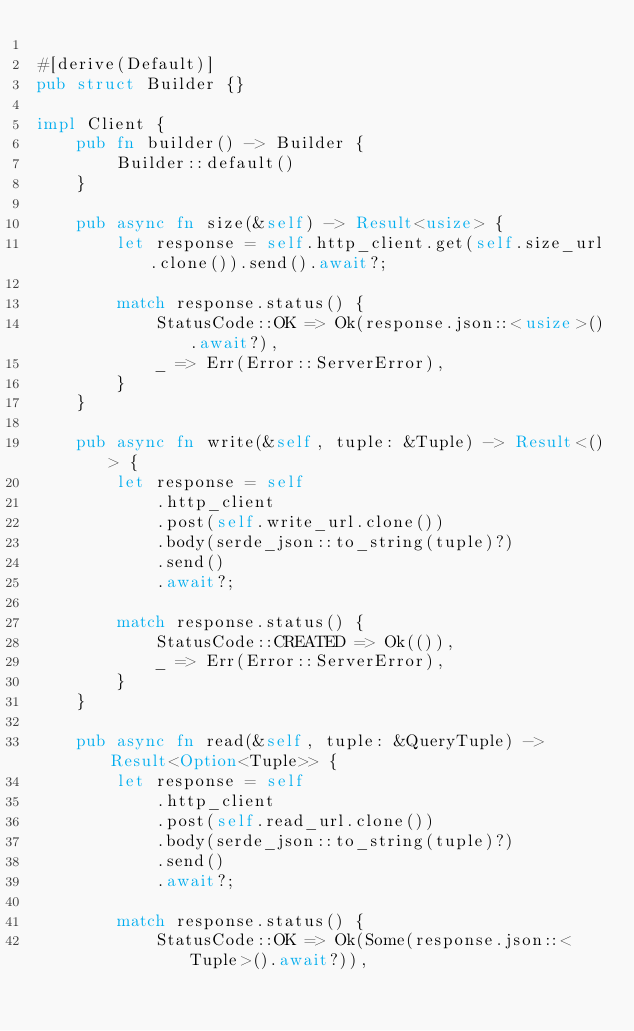<code> <loc_0><loc_0><loc_500><loc_500><_Rust_>
#[derive(Default)]
pub struct Builder {}

impl Client {
    pub fn builder() -> Builder {
        Builder::default()
    }

    pub async fn size(&self) -> Result<usize> {
        let response = self.http_client.get(self.size_url.clone()).send().await?;

        match response.status() {
            StatusCode::OK => Ok(response.json::<usize>().await?),
            _ => Err(Error::ServerError),
        }
    }

    pub async fn write(&self, tuple: &Tuple) -> Result<()> {
        let response = self
            .http_client
            .post(self.write_url.clone())
            .body(serde_json::to_string(tuple)?)
            .send()
            .await?;

        match response.status() {
            StatusCode::CREATED => Ok(()),
            _ => Err(Error::ServerError),
        }
    }

    pub async fn read(&self, tuple: &QueryTuple) -> Result<Option<Tuple>> {
        let response = self
            .http_client
            .post(self.read_url.clone())
            .body(serde_json::to_string(tuple)?)
            .send()
            .await?;

        match response.status() {
            StatusCode::OK => Ok(Some(response.json::<Tuple>().await?)),</code> 